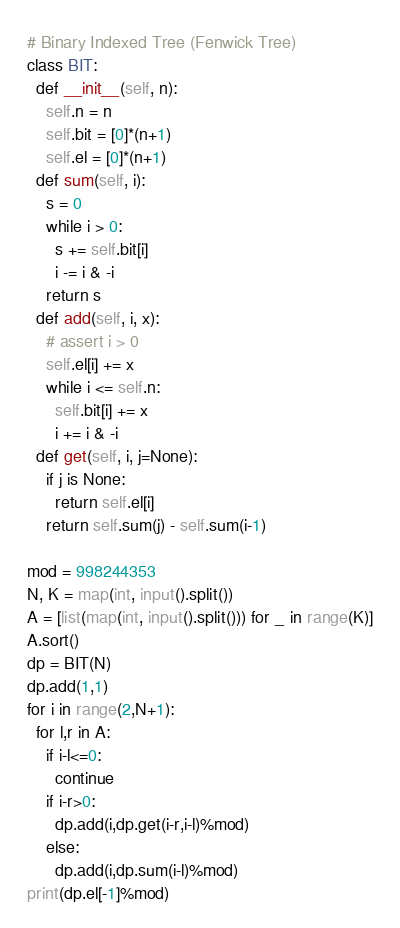<code> <loc_0><loc_0><loc_500><loc_500><_Python_># Binary Indexed Tree (Fenwick Tree)
class BIT:
  def __init__(self, n):
    self.n = n
    self.bit = [0]*(n+1)
    self.el = [0]*(n+1)
  def sum(self, i):
    s = 0
    while i > 0:
      s += self.bit[i]
      i -= i & -i
    return s
  def add(self, i, x):
    # assert i > 0
    self.el[i] += x
    while i <= self.n:
      self.bit[i] += x
      i += i & -i
  def get(self, i, j=None):
    if j is None:
      return self.el[i]
    return self.sum(j) - self.sum(i-1)

mod = 998244353
N, K = map(int, input().split())
A = [list(map(int, input().split())) for _ in range(K)]
A.sort()
dp = BIT(N)
dp.add(1,1)
for i in range(2,N+1):
  for l,r in A:
    if i-l<=0:
      continue
    if i-r>0:
      dp.add(i,dp.get(i-r,i-l)%mod)
    else:
      dp.add(i,dp.sum(i-l)%mod)
print(dp.el[-1]%mod)

</code> 